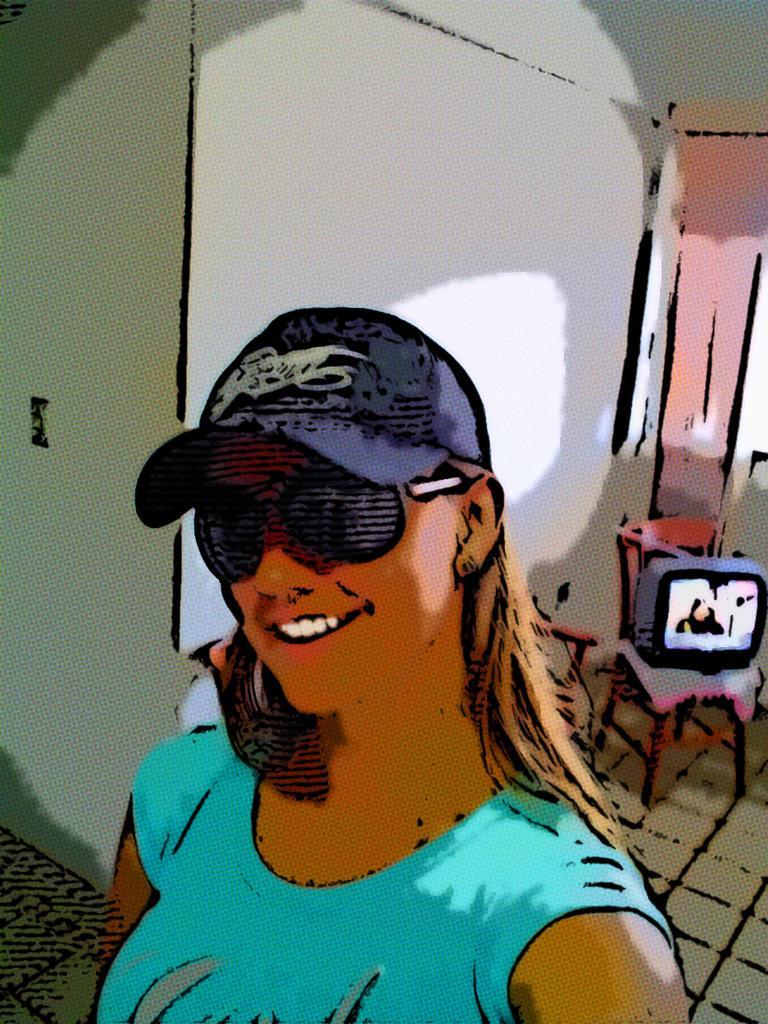Please provide a concise description of this image. This is an edited image. In the foreground there is a woman wearing t-shirt, cap, sun glasses, smiling and seems to be standing on the ground. In the background there is a wall, television placed on the chair and some other objects. 